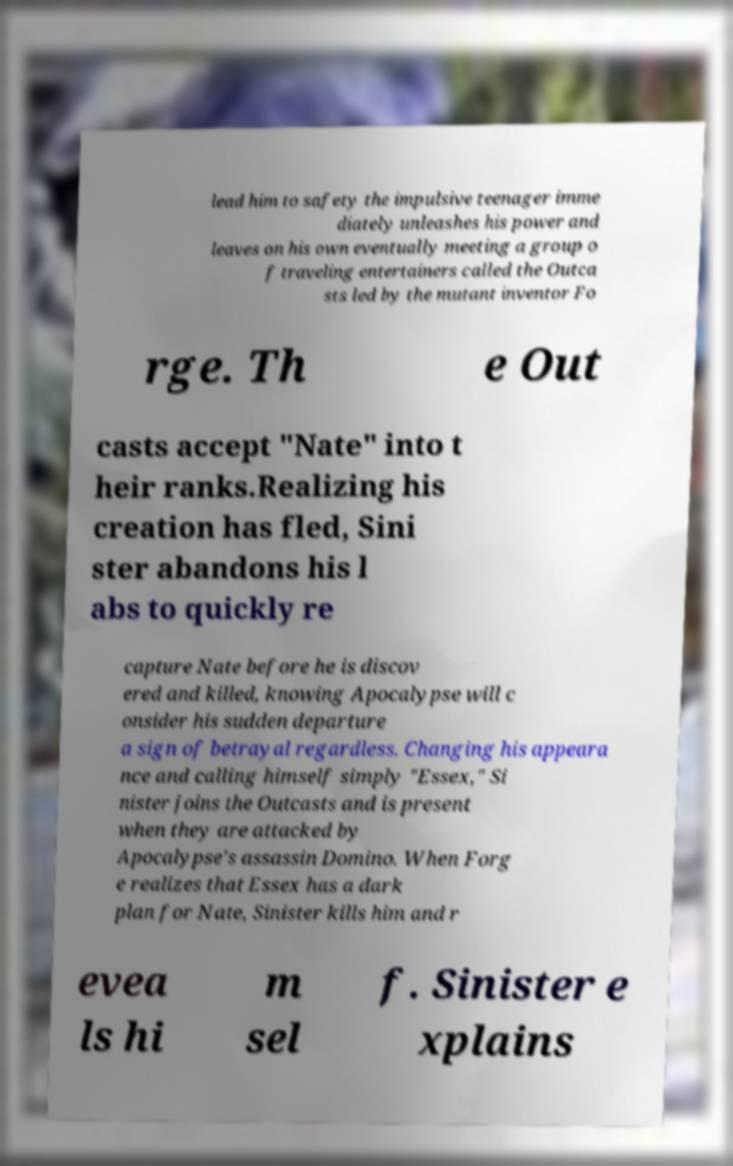I need the written content from this picture converted into text. Can you do that? lead him to safety the impulsive teenager imme diately unleashes his power and leaves on his own eventually meeting a group o f traveling entertainers called the Outca sts led by the mutant inventor Fo rge. Th e Out casts accept "Nate" into t heir ranks.Realizing his creation has fled, Sini ster abandons his l abs to quickly re capture Nate before he is discov ered and killed, knowing Apocalypse will c onsider his sudden departure a sign of betrayal regardless. Changing his appeara nce and calling himself simply "Essex," Si nister joins the Outcasts and is present when they are attacked by Apocalypse's assassin Domino. When Forg e realizes that Essex has a dark plan for Nate, Sinister kills him and r evea ls hi m sel f. Sinister e xplains 